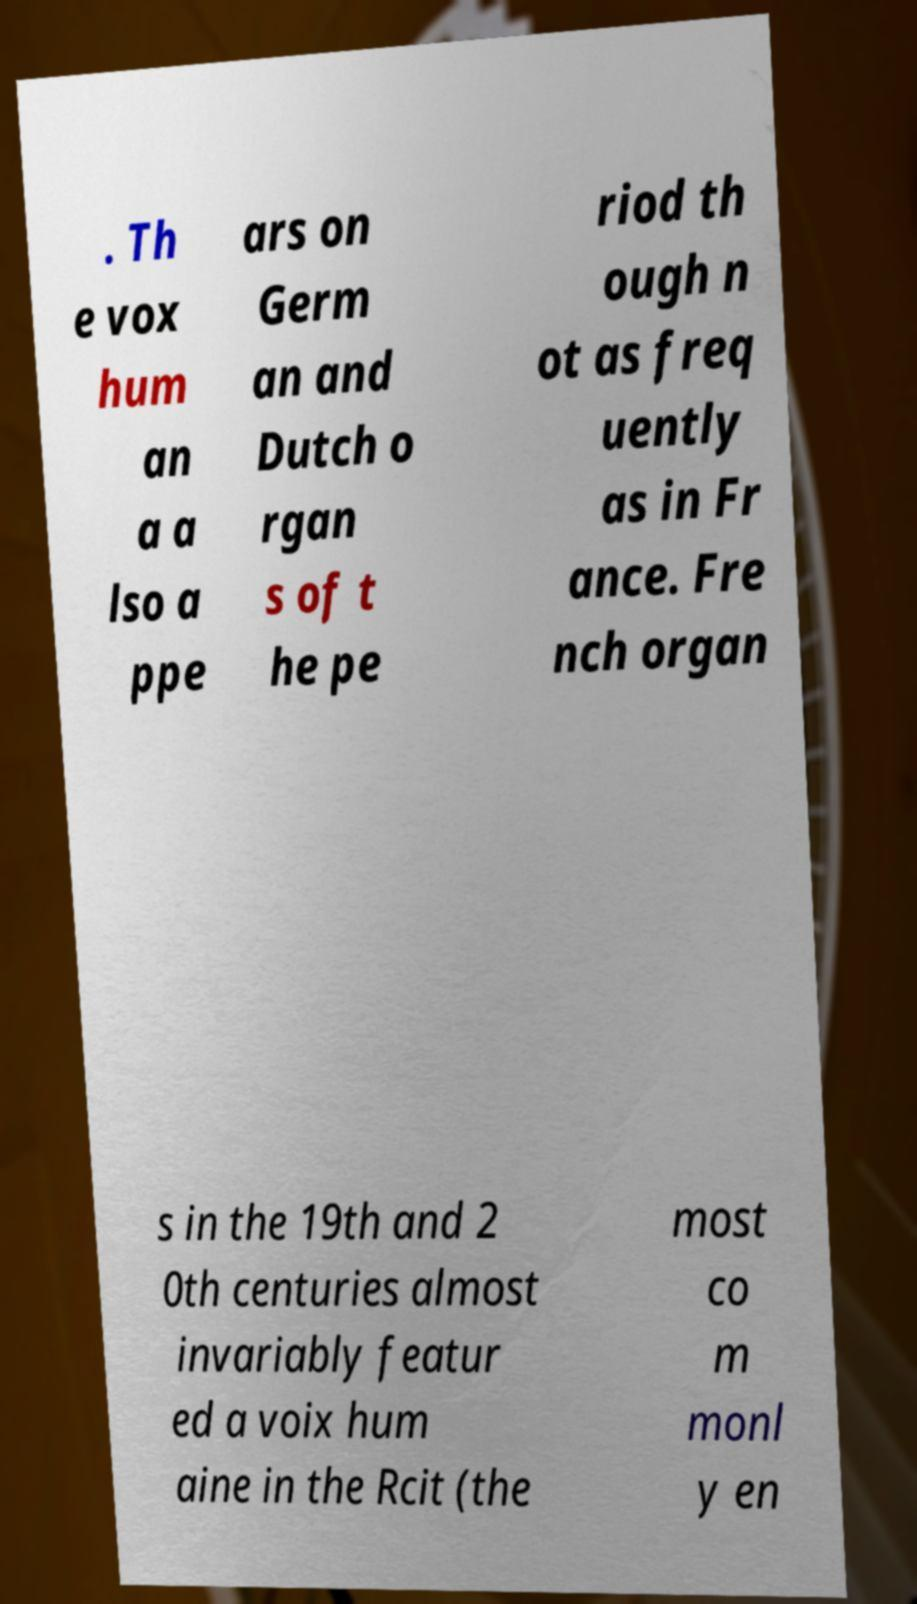There's text embedded in this image that I need extracted. Can you transcribe it verbatim? . Th e vox hum an a a lso a ppe ars on Germ an and Dutch o rgan s of t he pe riod th ough n ot as freq uently as in Fr ance. Fre nch organ s in the 19th and 2 0th centuries almost invariably featur ed a voix hum aine in the Rcit (the most co m monl y en 